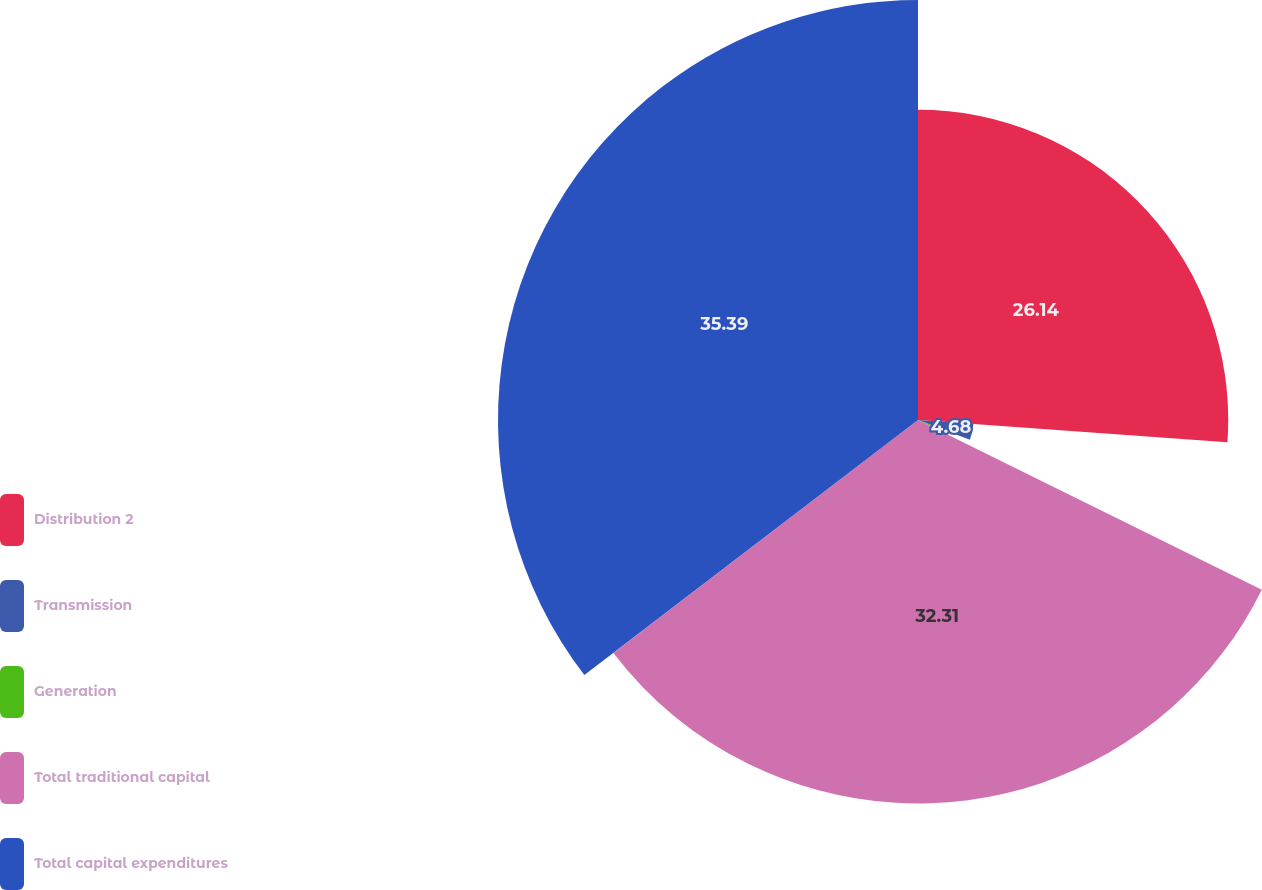Convert chart to OTSL. <chart><loc_0><loc_0><loc_500><loc_500><pie_chart><fcel>Distribution 2<fcel>Transmission<fcel>Generation<fcel>Total traditional capital<fcel>Total capital expenditures<nl><fcel>26.14%<fcel>4.68%<fcel>1.48%<fcel>32.31%<fcel>35.39%<nl></chart> 